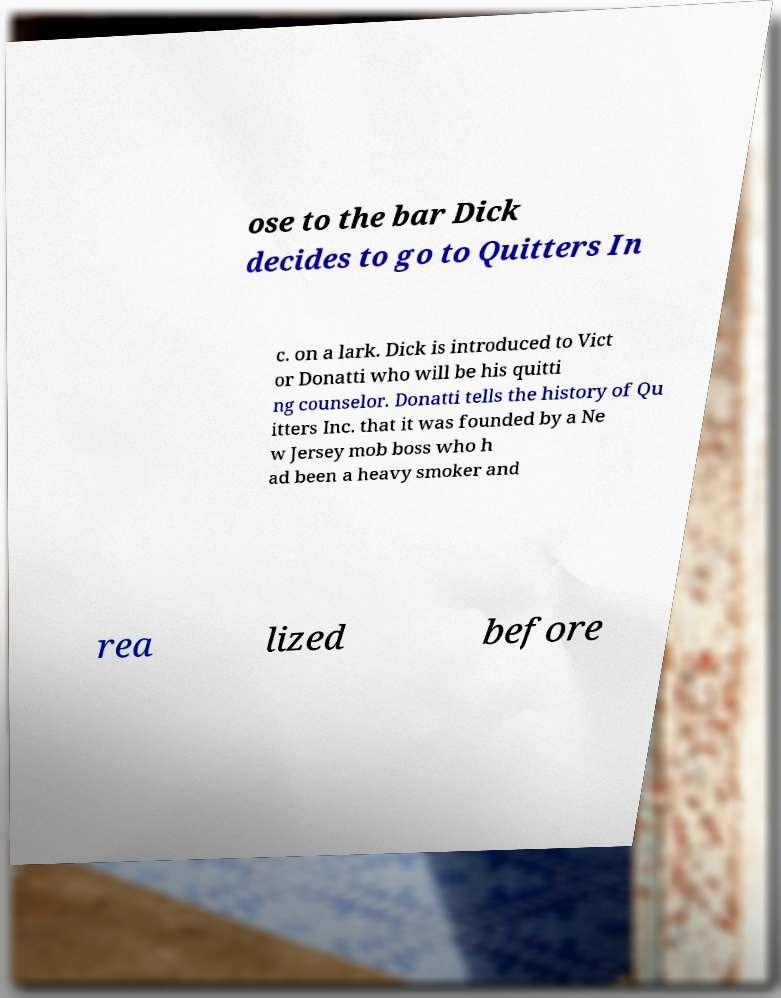I need the written content from this picture converted into text. Can you do that? ose to the bar Dick decides to go to Quitters In c. on a lark. Dick is introduced to Vict or Donatti who will be his quitti ng counselor. Donatti tells the history of Qu itters Inc. that it was founded by a Ne w Jersey mob boss who h ad been a heavy smoker and rea lized before 